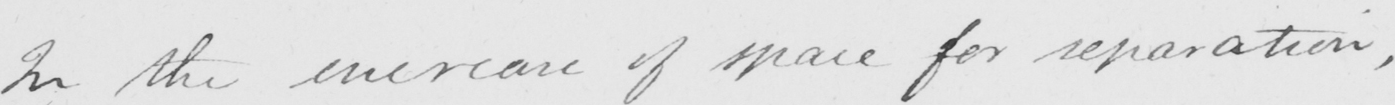Can you read and transcribe this handwriting? In the increase of space for separation , 